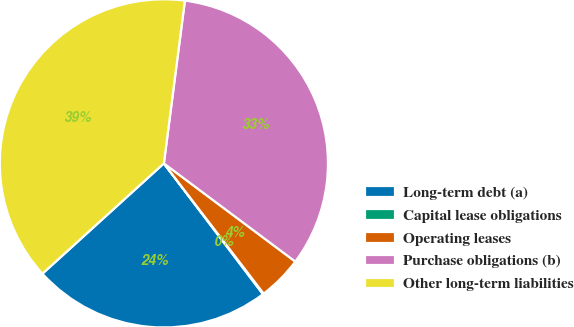Convert chart. <chart><loc_0><loc_0><loc_500><loc_500><pie_chart><fcel>Long-term debt (a)<fcel>Capital lease obligations<fcel>Operating leases<fcel>Purchase obligations (b)<fcel>Other long-term liabilities<nl><fcel>23.58%<fcel>0.09%<fcel>4.38%<fcel>33.17%<fcel>38.78%<nl></chart> 